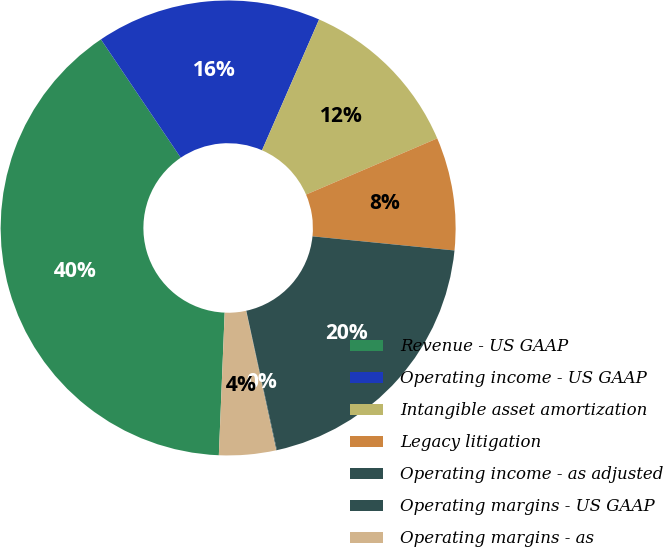<chart> <loc_0><loc_0><loc_500><loc_500><pie_chart><fcel>Revenue - US GAAP<fcel>Operating income - US GAAP<fcel>Intangible asset amortization<fcel>Legacy litigation<fcel>Operating income - as adjusted<fcel>Operating margins - US GAAP<fcel>Operating margins - as<nl><fcel>39.9%<fcel>15.99%<fcel>12.01%<fcel>8.02%<fcel>19.98%<fcel>0.05%<fcel>4.04%<nl></chart> 